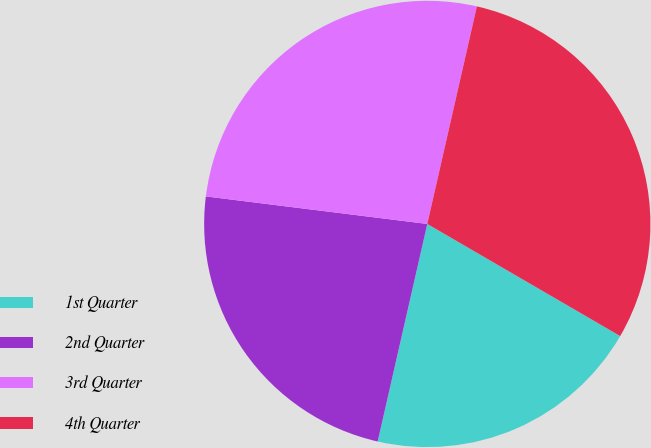<chart> <loc_0><loc_0><loc_500><loc_500><pie_chart><fcel>1st Quarter<fcel>2nd Quarter<fcel>3rd Quarter<fcel>4th Quarter<nl><fcel>20.19%<fcel>23.4%<fcel>26.6%<fcel>29.81%<nl></chart> 